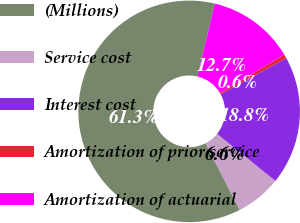Convert chart. <chart><loc_0><loc_0><loc_500><loc_500><pie_chart><fcel>(Millions)<fcel>Service cost<fcel>Interest cost<fcel>Amortization of prior service<fcel>Amortization of actuarial<nl><fcel>61.27%<fcel>6.65%<fcel>18.79%<fcel>0.58%<fcel>12.72%<nl></chart> 